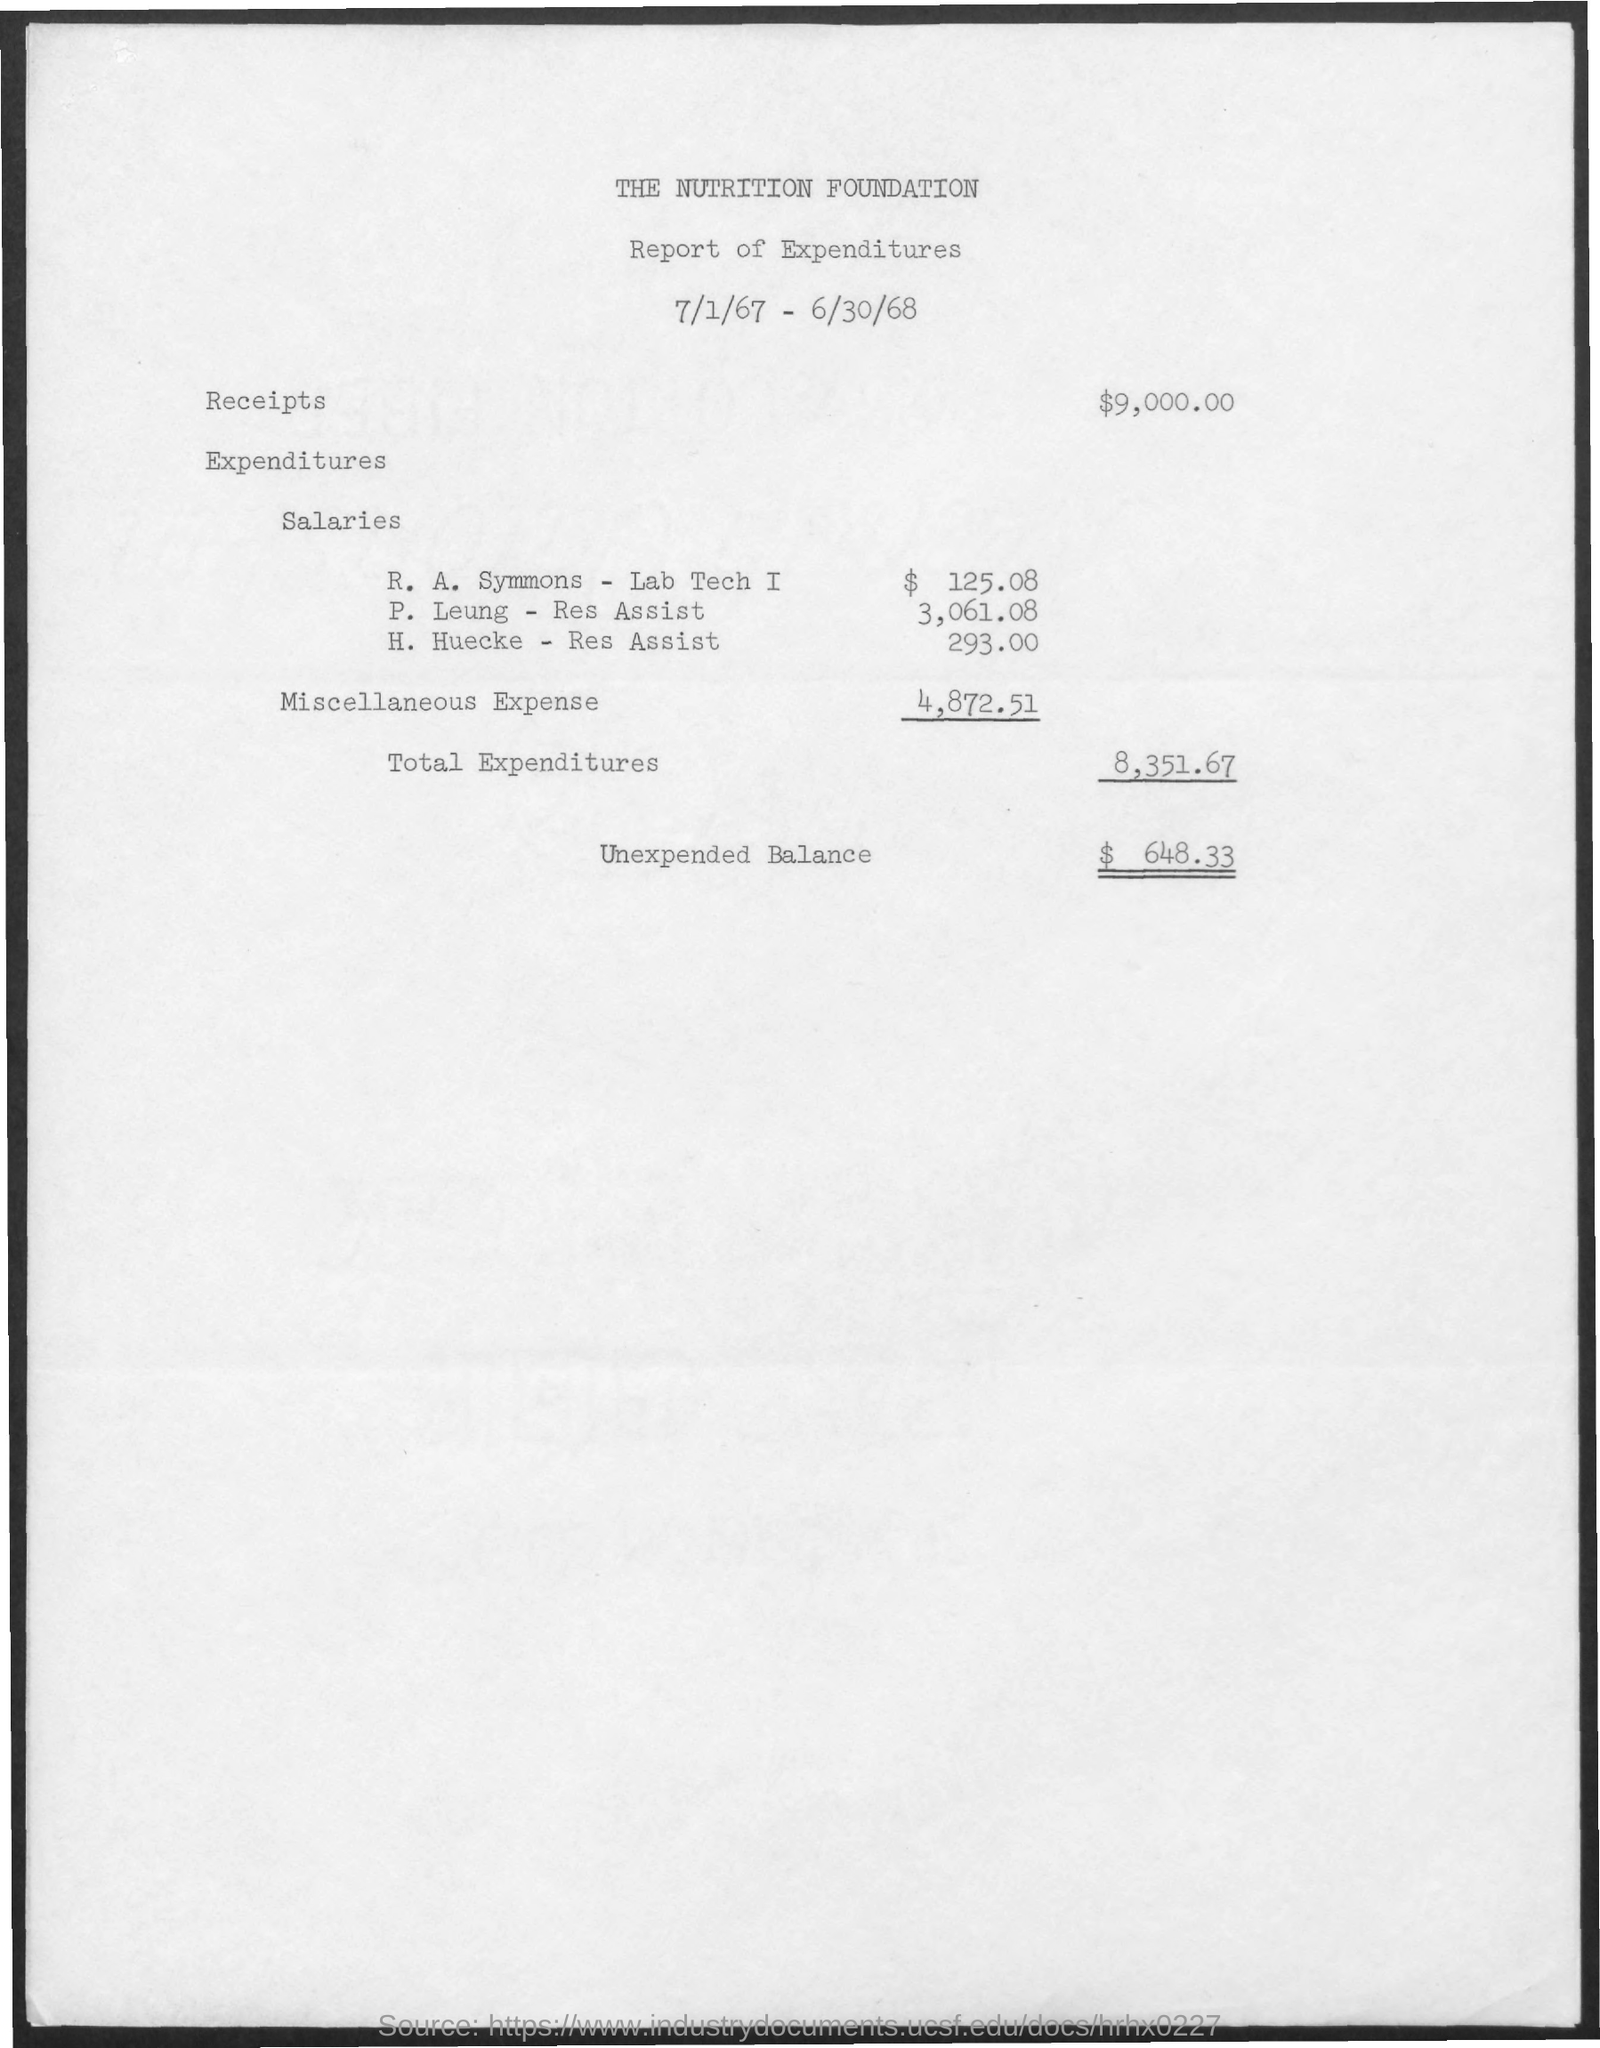List a handful of essential elements in this visual. According to the document, the unexpected balance is $648.33. The salary expenditure for R. A. Symmons, a lab tech I, is $125.08. 